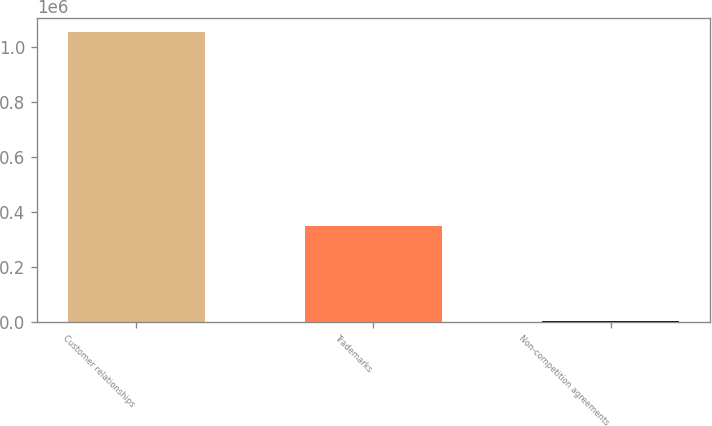Convert chart to OTSL. <chart><loc_0><loc_0><loc_500><loc_500><bar_chart><fcel>Customer relationships<fcel>Trademarks<fcel>Non-competition agreements<nl><fcel>1.05204e+06<fcel>346456<fcel>1894<nl></chart> 